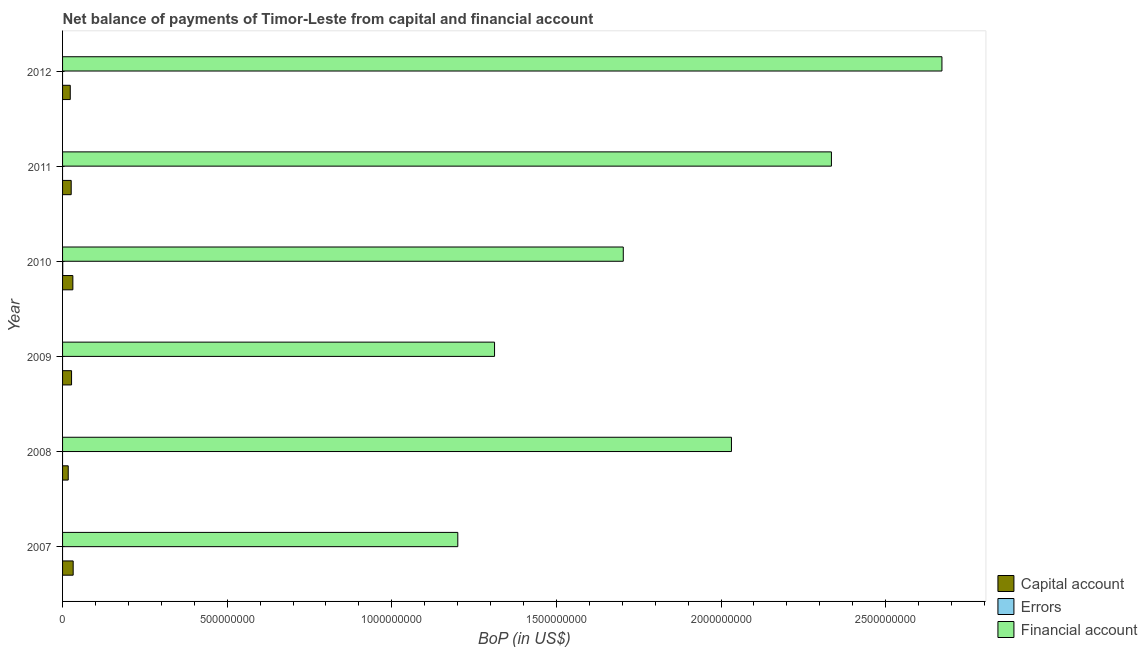How many different coloured bars are there?
Give a very brief answer. 3. How many groups of bars are there?
Give a very brief answer. 6. Are the number of bars on each tick of the Y-axis equal?
Your answer should be very brief. No. How many bars are there on the 1st tick from the bottom?
Provide a short and direct response. 2. In how many cases, is the number of bars for a given year not equal to the number of legend labels?
Your response must be concise. 5. Across all years, what is the maximum amount of financial account?
Provide a short and direct response. 2.67e+09. Across all years, what is the minimum amount of financial account?
Your response must be concise. 1.20e+09. In which year was the amount of net capital account maximum?
Your answer should be very brief. 2007. What is the total amount of net capital account in the graph?
Offer a terse response. 1.58e+08. What is the difference between the amount of financial account in 2009 and that in 2011?
Make the answer very short. -1.02e+09. What is the difference between the amount of financial account in 2007 and the amount of net capital account in 2011?
Keep it short and to the point. 1.17e+09. What is the average amount of net capital account per year?
Ensure brevity in your answer.  2.63e+07. In the year 2010, what is the difference between the amount of net capital account and amount of financial account?
Offer a terse response. -1.67e+09. What is the ratio of the amount of financial account in 2009 to that in 2012?
Ensure brevity in your answer.  0.49. Is the amount of financial account in 2007 less than that in 2012?
Your response must be concise. Yes. Is the difference between the amount of financial account in 2009 and 2012 greater than the difference between the amount of net capital account in 2009 and 2012?
Provide a short and direct response. No. What is the difference between the highest and the second highest amount of financial account?
Provide a short and direct response. 3.36e+08. What is the difference between the highest and the lowest amount of financial account?
Ensure brevity in your answer.  1.47e+09. In how many years, is the amount of net capital account greater than the average amount of net capital account taken over all years?
Make the answer very short. 3. Is the sum of the amount of net capital account in 2008 and 2011 greater than the maximum amount of errors across all years?
Your response must be concise. Yes. How many bars are there?
Offer a very short reply. 13. Are the values on the major ticks of X-axis written in scientific E-notation?
Ensure brevity in your answer.  No. Does the graph contain any zero values?
Your answer should be compact. Yes. Does the graph contain grids?
Your answer should be compact. No. Where does the legend appear in the graph?
Provide a succinct answer. Bottom right. How many legend labels are there?
Ensure brevity in your answer.  3. How are the legend labels stacked?
Offer a terse response. Vertical. What is the title of the graph?
Offer a very short reply. Net balance of payments of Timor-Leste from capital and financial account. What is the label or title of the X-axis?
Make the answer very short. BoP (in US$). What is the label or title of the Y-axis?
Give a very brief answer. Year. What is the BoP (in US$) in Capital account in 2007?
Give a very brief answer. 3.22e+07. What is the BoP (in US$) of Financial account in 2007?
Provide a short and direct response. 1.20e+09. What is the BoP (in US$) of Capital account in 2008?
Make the answer very short. 1.72e+07. What is the BoP (in US$) in Financial account in 2008?
Provide a short and direct response. 2.03e+09. What is the BoP (in US$) in Capital account in 2009?
Offer a terse response. 2.73e+07. What is the BoP (in US$) of Financial account in 2009?
Your answer should be compact. 1.31e+09. What is the BoP (in US$) of Capital account in 2010?
Provide a short and direct response. 3.13e+07. What is the BoP (in US$) of Errors in 2010?
Give a very brief answer. 5.13e+05. What is the BoP (in US$) of Financial account in 2010?
Make the answer very short. 1.70e+09. What is the BoP (in US$) of Capital account in 2011?
Your answer should be very brief. 2.62e+07. What is the BoP (in US$) in Financial account in 2011?
Provide a succinct answer. 2.34e+09. What is the BoP (in US$) in Capital account in 2012?
Ensure brevity in your answer.  2.34e+07. What is the BoP (in US$) of Errors in 2012?
Offer a terse response. 0. What is the BoP (in US$) in Financial account in 2012?
Provide a succinct answer. 2.67e+09. Across all years, what is the maximum BoP (in US$) in Capital account?
Offer a terse response. 3.22e+07. Across all years, what is the maximum BoP (in US$) in Errors?
Provide a succinct answer. 5.13e+05. Across all years, what is the maximum BoP (in US$) in Financial account?
Provide a succinct answer. 2.67e+09. Across all years, what is the minimum BoP (in US$) in Capital account?
Keep it short and to the point. 1.72e+07. Across all years, what is the minimum BoP (in US$) in Errors?
Ensure brevity in your answer.  0. Across all years, what is the minimum BoP (in US$) of Financial account?
Keep it short and to the point. 1.20e+09. What is the total BoP (in US$) of Capital account in the graph?
Your response must be concise. 1.58e+08. What is the total BoP (in US$) of Errors in the graph?
Your response must be concise. 5.13e+05. What is the total BoP (in US$) in Financial account in the graph?
Provide a succinct answer. 1.13e+1. What is the difference between the BoP (in US$) of Capital account in 2007 and that in 2008?
Your response must be concise. 1.50e+07. What is the difference between the BoP (in US$) in Financial account in 2007 and that in 2008?
Offer a terse response. -8.31e+08. What is the difference between the BoP (in US$) of Capital account in 2007 and that in 2009?
Provide a succinct answer. 4.88e+06. What is the difference between the BoP (in US$) in Financial account in 2007 and that in 2009?
Keep it short and to the point. -1.12e+08. What is the difference between the BoP (in US$) in Capital account in 2007 and that in 2010?
Your response must be concise. 9.62e+05. What is the difference between the BoP (in US$) in Financial account in 2007 and that in 2010?
Your answer should be compact. -5.03e+08. What is the difference between the BoP (in US$) in Capital account in 2007 and that in 2011?
Provide a succinct answer. 5.99e+06. What is the difference between the BoP (in US$) of Financial account in 2007 and that in 2011?
Your answer should be compact. -1.13e+09. What is the difference between the BoP (in US$) in Capital account in 2007 and that in 2012?
Make the answer very short. 8.81e+06. What is the difference between the BoP (in US$) of Financial account in 2007 and that in 2012?
Provide a short and direct response. -1.47e+09. What is the difference between the BoP (in US$) in Capital account in 2008 and that in 2009?
Offer a terse response. -1.01e+07. What is the difference between the BoP (in US$) in Financial account in 2008 and that in 2009?
Keep it short and to the point. 7.20e+08. What is the difference between the BoP (in US$) in Capital account in 2008 and that in 2010?
Make the answer very short. -1.40e+07. What is the difference between the BoP (in US$) of Financial account in 2008 and that in 2010?
Provide a succinct answer. 3.29e+08. What is the difference between the BoP (in US$) of Capital account in 2008 and that in 2011?
Provide a short and direct response. -8.99e+06. What is the difference between the BoP (in US$) in Financial account in 2008 and that in 2011?
Make the answer very short. -3.04e+08. What is the difference between the BoP (in US$) of Capital account in 2008 and that in 2012?
Provide a short and direct response. -6.18e+06. What is the difference between the BoP (in US$) in Financial account in 2008 and that in 2012?
Your answer should be compact. -6.39e+08. What is the difference between the BoP (in US$) of Capital account in 2009 and that in 2010?
Your answer should be compact. -3.92e+06. What is the difference between the BoP (in US$) of Financial account in 2009 and that in 2010?
Give a very brief answer. -3.91e+08. What is the difference between the BoP (in US$) of Capital account in 2009 and that in 2011?
Provide a succinct answer. 1.11e+06. What is the difference between the BoP (in US$) in Financial account in 2009 and that in 2011?
Provide a succinct answer. -1.02e+09. What is the difference between the BoP (in US$) of Capital account in 2009 and that in 2012?
Offer a very short reply. 3.92e+06. What is the difference between the BoP (in US$) of Financial account in 2009 and that in 2012?
Ensure brevity in your answer.  -1.36e+09. What is the difference between the BoP (in US$) of Capital account in 2010 and that in 2011?
Offer a terse response. 5.03e+06. What is the difference between the BoP (in US$) in Financial account in 2010 and that in 2011?
Make the answer very short. -6.32e+08. What is the difference between the BoP (in US$) of Capital account in 2010 and that in 2012?
Your response must be concise. 7.84e+06. What is the difference between the BoP (in US$) in Financial account in 2010 and that in 2012?
Your answer should be compact. -9.68e+08. What is the difference between the BoP (in US$) in Capital account in 2011 and that in 2012?
Offer a very short reply. 2.81e+06. What is the difference between the BoP (in US$) of Financial account in 2011 and that in 2012?
Your response must be concise. -3.36e+08. What is the difference between the BoP (in US$) in Capital account in 2007 and the BoP (in US$) in Financial account in 2008?
Your answer should be very brief. -2.00e+09. What is the difference between the BoP (in US$) of Capital account in 2007 and the BoP (in US$) of Financial account in 2009?
Keep it short and to the point. -1.28e+09. What is the difference between the BoP (in US$) of Capital account in 2007 and the BoP (in US$) of Errors in 2010?
Keep it short and to the point. 3.17e+07. What is the difference between the BoP (in US$) in Capital account in 2007 and the BoP (in US$) in Financial account in 2010?
Provide a succinct answer. -1.67e+09. What is the difference between the BoP (in US$) of Capital account in 2007 and the BoP (in US$) of Financial account in 2011?
Your answer should be compact. -2.30e+09. What is the difference between the BoP (in US$) of Capital account in 2007 and the BoP (in US$) of Financial account in 2012?
Provide a short and direct response. -2.64e+09. What is the difference between the BoP (in US$) of Capital account in 2008 and the BoP (in US$) of Financial account in 2009?
Your answer should be very brief. -1.29e+09. What is the difference between the BoP (in US$) of Capital account in 2008 and the BoP (in US$) of Errors in 2010?
Keep it short and to the point. 1.67e+07. What is the difference between the BoP (in US$) of Capital account in 2008 and the BoP (in US$) of Financial account in 2010?
Your answer should be very brief. -1.69e+09. What is the difference between the BoP (in US$) of Capital account in 2008 and the BoP (in US$) of Financial account in 2011?
Ensure brevity in your answer.  -2.32e+09. What is the difference between the BoP (in US$) in Capital account in 2008 and the BoP (in US$) in Financial account in 2012?
Ensure brevity in your answer.  -2.65e+09. What is the difference between the BoP (in US$) in Capital account in 2009 and the BoP (in US$) in Errors in 2010?
Offer a very short reply. 2.68e+07. What is the difference between the BoP (in US$) of Capital account in 2009 and the BoP (in US$) of Financial account in 2010?
Your answer should be compact. -1.68e+09. What is the difference between the BoP (in US$) in Capital account in 2009 and the BoP (in US$) in Financial account in 2011?
Offer a terse response. -2.31e+09. What is the difference between the BoP (in US$) in Capital account in 2009 and the BoP (in US$) in Financial account in 2012?
Give a very brief answer. -2.64e+09. What is the difference between the BoP (in US$) in Capital account in 2010 and the BoP (in US$) in Financial account in 2011?
Your answer should be very brief. -2.30e+09. What is the difference between the BoP (in US$) in Errors in 2010 and the BoP (in US$) in Financial account in 2011?
Offer a very short reply. -2.33e+09. What is the difference between the BoP (in US$) of Capital account in 2010 and the BoP (in US$) of Financial account in 2012?
Give a very brief answer. -2.64e+09. What is the difference between the BoP (in US$) in Errors in 2010 and the BoP (in US$) in Financial account in 2012?
Provide a short and direct response. -2.67e+09. What is the difference between the BoP (in US$) in Capital account in 2011 and the BoP (in US$) in Financial account in 2012?
Give a very brief answer. -2.64e+09. What is the average BoP (in US$) in Capital account per year?
Your response must be concise. 2.63e+07. What is the average BoP (in US$) in Errors per year?
Make the answer very short. 8.55e+04. What is the average BoP (in US$) in Financial account per year?
Make the answer very short. 1.88e+09. In the year 2007, what is the difference between the BoP (in US$) in Capital account and BoP (in US$) in Financial account?
Make the answer very short. -1.17e+09. In the year 2008, what is the difference between the BoP (in US$) in Capital account and BoP (in US$) in Financial account?
Your answer should be very brief. -2.01e+09. In the year 2009, what is the difference between the BoP (in US$) in Capital account and BoP (in US$) in Financial account?
Your answer should be very brief. -1.28e+09. In the year 2010, what is the difference between the BoP (in US$) in Capital account and BoP (in US$) in Errors?
Give a very brief answer. 3.07e+07. In the year 2010, what is the difference between the BoP (in US$) in Capital account and BoP (in US$) in Financial account?
Keep it short and to the point. -1.67e+09. In the year 2010, what is the difference between the BoP (in US$) of Errors and BoP (in US$) of Financial account?
Your answer should be compact. -1.70e+09. In the year 2011, what is the difference between the BoP (in US$) of Capital account and BoP (in US$) of Financial account?
Offer a terse response. -2.31e+09. In the year 2012, what is the difference between the BoP (in US$) of Capital account and BoP (in US$) of Financial account?
Offer a very short reply. -2.65e+09. What is the ratio of the BoP (in US$) of Capital account in 2007 to that in 2008?
Your answer should be compact. 1.87. What is the ratio of the BoP (in US$) of Financial account in 2007 to that in 2008?
Ensure brevity in your answer.  0.59. What is the ratio of the BoP (in US$) in Capital account in 2007 to that in 2009?
Make the answer very short. 1.18. What is the ratio of the BoP (in US$) in Financial account in 2007 to that in 2009?
Your answer should be very brief. 0.91. What is the ratio of the BoP (in US$) in Capital account in 2007 to that in 2010?
Make the answer very short. 1.03. What is the ratio of the BoP (in US$) in Financial account in 2007 to that in 2010?
Provide a succinct answer. 0.7. What is the ratio of the BoP (in US$) in Capital account in 2007 to that in 2011?
Give a very brief answer. 1.23. What is the ratio of the BoP (in US$) in Financial account in 2007 to that in 2011?
Your answer should be very brief. 0.51. What is the ratio of the BoP (in US$) in Capital account in 2007 to that in 2012?
Make the answer very short. 1.38. What is the ratio of the BoP (in US$) of Financial account in 2007 to that in 2012?
Your response must be concise. 0.45. What is the ratio of the BoP (in US$) of Capital account in 2008 to that in 2009?
Your answer should be compact. 0.63. What is the ratio of the BoP (in US$) of Financial account in 2008 to that in 2009?
Your response must be concise. 1.55. What is the ratio of the BoP (in US$) of Capital account in 2008 to that in 2010?
Your answer should be very brief. 0.55. What is the ratio of the BoP (in US$) of Financial account in 2008 to that in 2010?
Provide a succinct answer. 1.19. What is the ratio of the BoP (in US$) of Capital account in 2008 to that in 2011?
Your answer should be very brief. 0.66. What is the ratio of the BoP (in US$) in Financial account in 2008 to that in 2011?
Provide a short and direct response. 0.87. What is the ratio of the BoP (in US$) in Capital account in 2008 to that in 2012?
Offer a very short reply. 0.74. What is the ratio of the BoP (in US$) in Financial account in 2008 to that in 2012?
Keep it short and to the point. 0.76. What is the ratio of the BoP (in US$) in Capital account in 2009 to that in 2010?
Your response must be concise. 0.87. What is the ratio of the BoP (in US$) of Financial account in 2009 to that in 2010?
Your answer should be very brief. 0.77. What is the ratio of the BoP (in US$) in Capital account in 2009 to that in 2011?
Give a very brief answer. 1.04. What is the ratio of the BoP (in US$) of Financial account in 2009 to that in 2011?
Offer a very short reply. 0.56. What is the ratio of the BoP (in US$) of Capital account in 2009 to that in 2012?
Provide a succinct answer. 1.17. What is the ratio of the BoP (in US$) in Financial account in 2009 to that in 2012?
Give a very brief answer. 0.49. What is the ratio of the BoP (in US$) of Capital account in 2010 to that in 2011?
Your answer should be very brief. 1.19. What is the ratio of the BoP (in US$) in Financial account in 2010 to that in 2011?
Give a very brief answer. 0.73. What is the ratio of the BoP (in US$) of Capital account in 2010 to that in 2012?
Your answer should be compact. 1.34. What is the ratio of the BoP (in US$) in Financial account in 2010 to that in 2012?
Your answer should be compact. 0.64. What is the ratio of the BoP (in US$) of Capital account in 2011 to that in 2012?
Ensure brevity in your answer.  1.12. What is the ratio of the BoP (in US$) in Financial account in 2011 to that in 2012?
Your answer should be compact. 0.87. What is the difference between the highest and the second highest BoP (in US$) of Capital account?
Ensure brevity in your answer.  9.62e+05. What is the difference between the highest and the second highest BoP (in US$) in Financial account?
Keep it short and to the point. 3.36e+08. What is the difference between the highest and the lowest BoP (in US$) in Capital account?
Make the answer very short. 1.50e+07. What is the difference between the highest and the lowest BoP (in US$) in Errors?
Provide a short and direct response. 5.13e+05. What is the difference between the highest and the lowest BoP (in US$) of Financial account?
Offer a very short reply. 1.47e+09. 